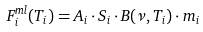<formula> <loc_0><loc_0><loc_500><loc_500>F ^ { m l } _ { i } ( T _ { i } ) = A _ { i } \cdot S _ { i } \cdot B ( \nu , T _ { i } ) \cdot m _ { i }</formula> 